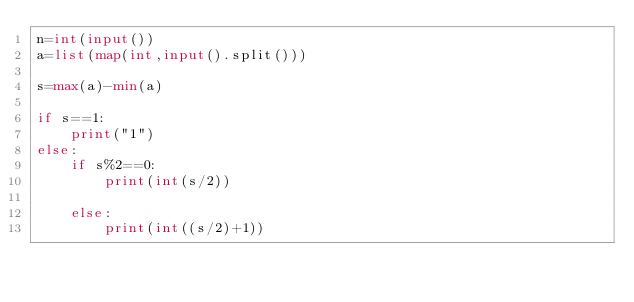Convert code to text. <code><loc_0><loc_0><loc_500><loc_500><_Python_>n=int(input())
a=list(map(int,input().split()))

s=max(a)-min(a)

if s==1:
    print("1")
else:
    if s%2==0:
        print(int(s/2))
        
    else:
        print(int((s/2)+1))
</code> 